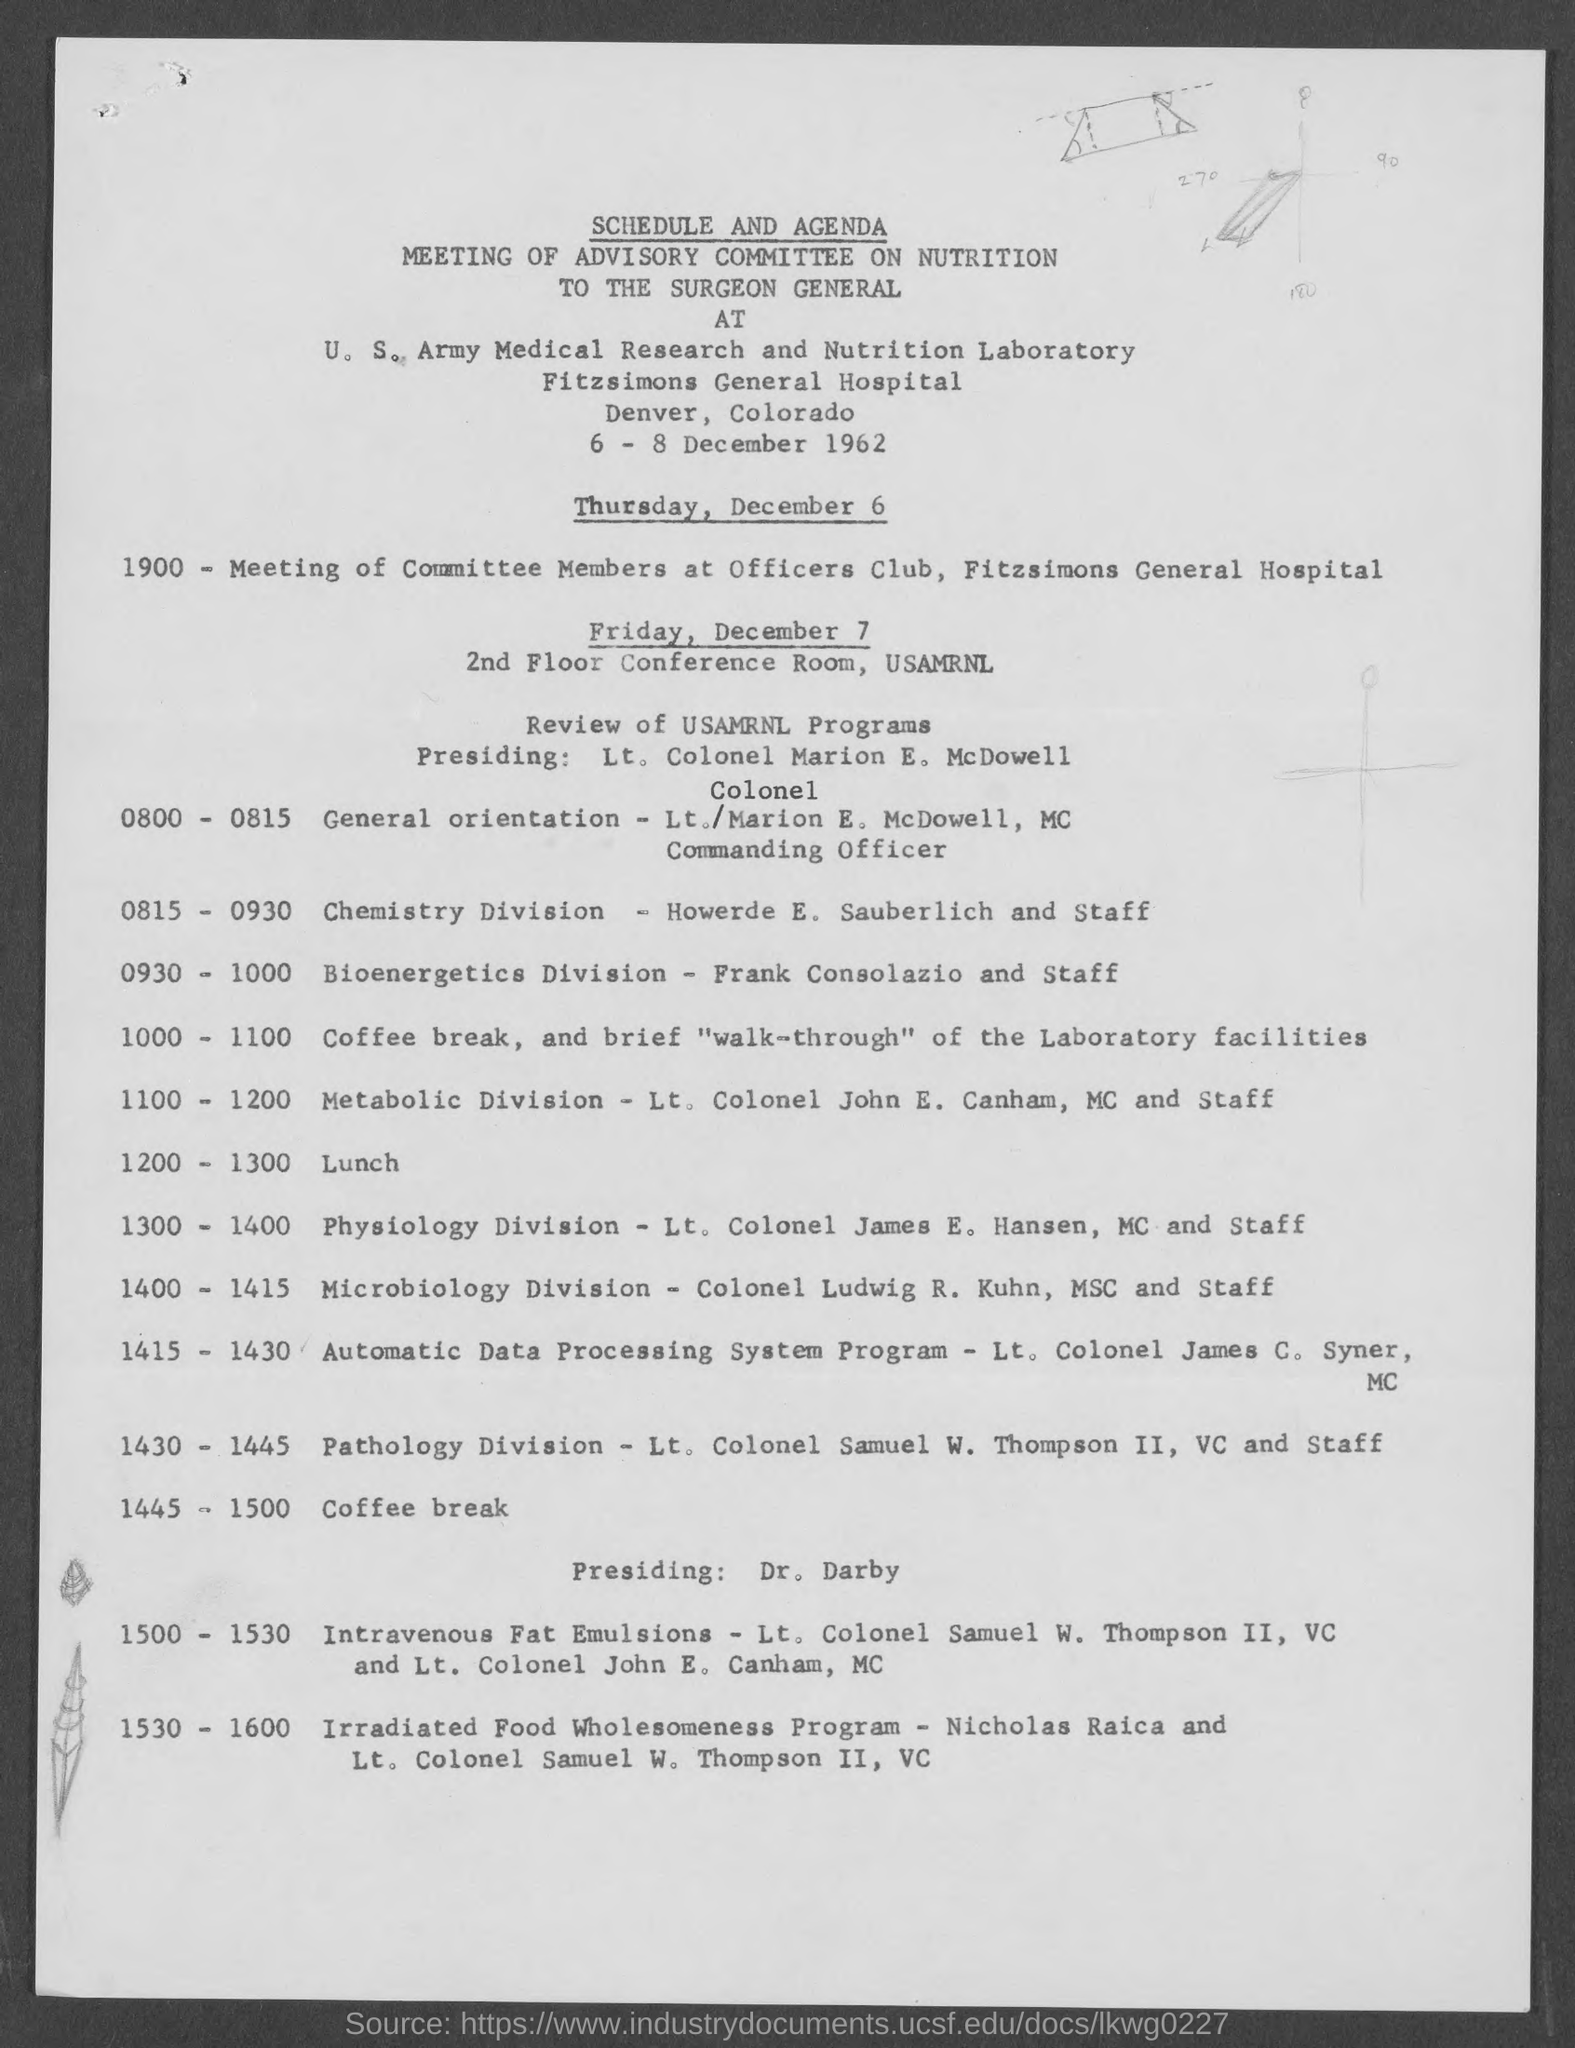What is the heading of document on top?
Your answer should be very brief. Schedule and agenda. What is the address for schedule on thursday, december 6?
Provide a short and direct response. Fitzsimons General Hospital. What is the address for schedule on friday, december 7?
Your answer should be very brief. 2nd Floor Conference Room , USAMRNL. 